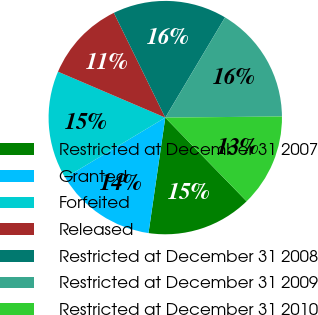Convert chart to OTSL. <chart><loc_0><loc_0><loc_500><loc_500><pie_chart><fcel>Restricted at December 31 2007<fcel>Granted<fcel>Forfeited<fcel>Released<fcel>Restricted at December 31 2008<fcel>Restricted at December 31 2009<fcel>Restricted at December 31 2010<nl><fcel>14.57%<fcel>14.09%<fcel>15.05%<fcel>11.3%<fcel>15.82%<fcel>16.29%<fcel>12.88%<nl></chart> 